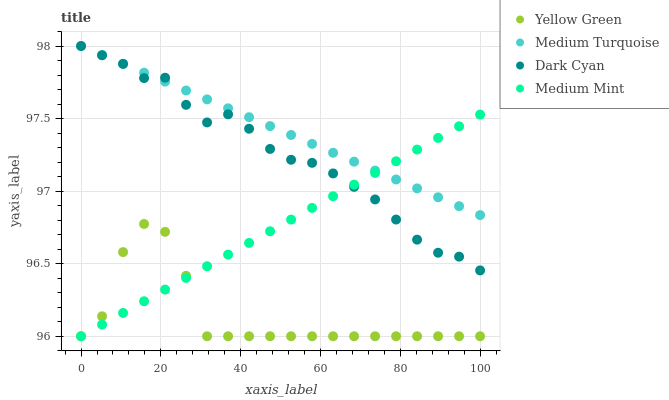Does Yellow Green have the minimum area under the curve?
Answer yes or no. Yes. Does Medium Turquoise have the maximum area under the curve?
Answer yes or no. Yes. Does Medium Mint have the minimum area under the curve?
Answer yes or no. No. Does Medium Mint have the maximum area under the curve?
Answer yes or no. No. Is Medium Turquoise the smoothest?
Answer yes or no. Yes. Is Yellow Green the roughest?
Answer yes or no. Yes. Is Medium Mint the smoothest?
Answer yes or no. No. Is Medium Mint the roughest?
Answer yes or no. No. Does Medium Mint have the lowest value?
Answer yes or no. Yes. Does Medium Turquoise have the lowest value?
Answer yes or no. No. Does Medium Turquoise have the highest value?
Answer yes or no. Yes. Does Medium Mint have the highest value?
Answer yes or no. No. Is Yellow Green less than Dark Cyan?
Answer yes or no. Yes. Is Dark Cyan greater than Yellow Green?
Answer yes or no. Yes. Does Medium Mint intersect Dark Cyan?
Answer yes or no. Yes. Is Medium Mint less than Dark Cyan?
Answer yes or no. No. Is Medium Mint greater than Dark Cyan?
Answer yes or no. No. Does Yellow Green intersect Dark Cyan?
Answer yes or no. No. 